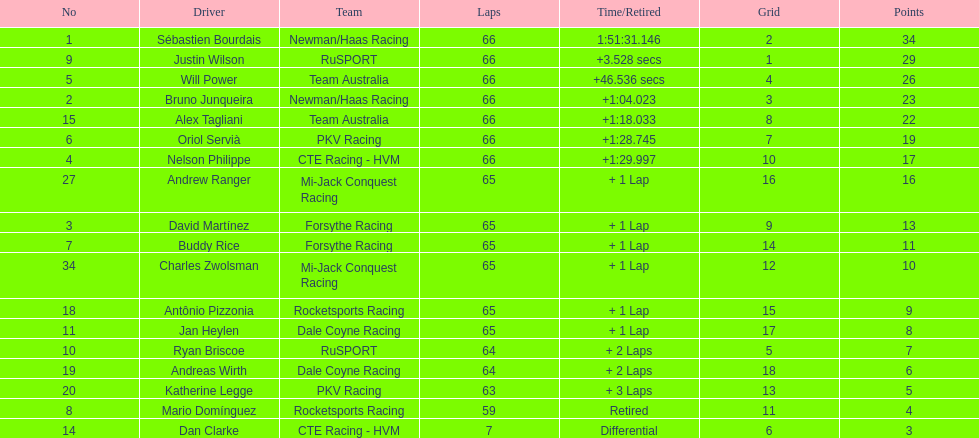At the 2006 gran premio telmex, who finished last? Dan Clarke. 